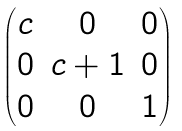Convert formula to latex. <formula><loc_0><loc_0><loc_500><loc_500>\begin{pmatrix} c & 0 & 0 \\ 0 & c + 1 & 0 \\ 0 & 0 & 1 \end{pmatrix}</formula> 